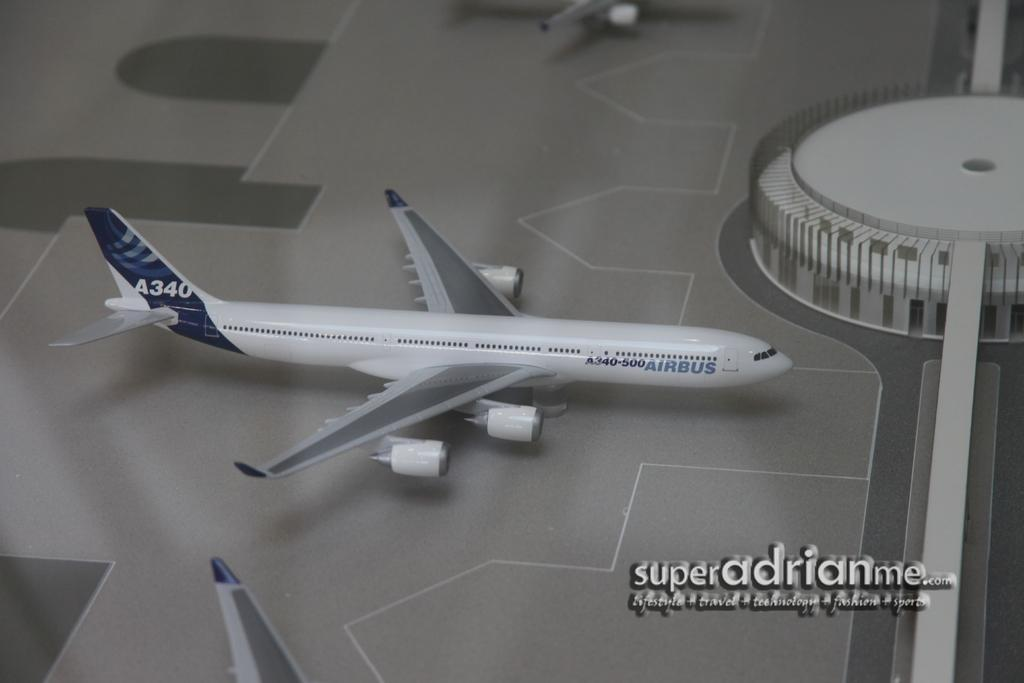What is the color of the plane in the image? The plane in the image is white. Where is the plane located in the image? The plane is on a runway. What can be seen in the right corner of the image? There is an object in the right corner of the image. What year is the plane from in the image? The provided facts do not mention the year the plane is from, so it cannot be determined from the image. 